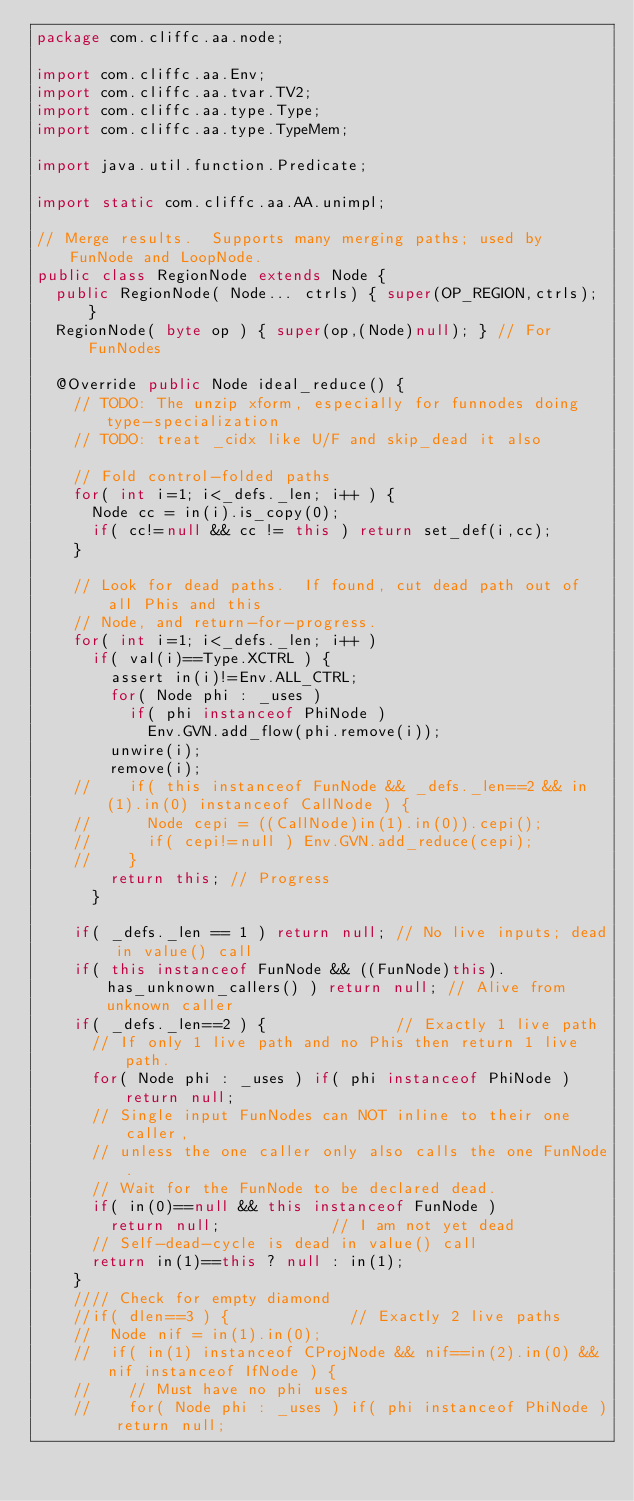Convert code to text. <code><loc_0><loc_0><loc_500><loc_500><_Java_>package com.cliffc.aa.node;

import com.cliffc.aa.Env;
import com.cliffc.aa.tvar.TV2;
import com.cliffc.aa.type.Type;
import com.cliffc.aa.type.TypeMem;

import java.util.function.Predicate;

import static com.cliffc.aa.AA.unimpl;

// Merge results.  Supports many merging paths; used by FunNode and LoopNode.
public class RegionNode extends Node {
  public RegionNode( Node... ctrls) { super(OP_REGION,ctrls); }
  RegionNode( byte op ) { super(op,(Node)null); } // For FunNodes

  @Override public Node ideal_reduce() {
    // TODO: The unzip xform, especially for funnodes doing type-specialization
    // TODO: treat _cidx like U/F and skip_dead it also

    // Fold control-folded paths
    for( int i=1; i<_defs._len; i++ ) {
      Node cc = in(i).is_copy(0);
      if( cc!=null && cc != this ) return set_def(i,cc);
    }

    // Look for dead paths.  If found, cut dead path out of all Phis and this
    // Node, and return-for-progress.
    for( int i=1; i<_defs._len; i++ )
      if( val(i)==Type.XCTRL ) {
        assert in(i)!=Env.ALL_CTRL;
        for( Node phi : _uses )
          if( phi instanceof PhiNode )
            Env.GVN.add_flow(phi.remove(i));
        unwire(i);
        remove(i);
    //    if( this instanceof FunNode && _defs._len==2 && in(1).in(0) instanceof CallNode ) {
    //      Node cepi = ((CallNode)in(1).in(0)).cepi();
    //      if( cepi!=null ) Env.GVN.add_reduce(cepi);
    //    }
        return this; // Progress
      }

    if( _defs._len == 1 ) return null; // No live inputs; dead in value() call
    if( this instanceof FunNode && ((FunNode)this).has_unknown_callers() ) return null; // Alive from unknown caller
    if( _defs._len==2 ) {              // Exactly 1 live path
      // If only 1 live path and no Phis then return 1 live path.
      for( Node phi : _uses ) if( phi instanceof PhiNode ) return null;
      // Single input FunNodes can NOT inline to their one caller,
      // unless the one caller only also calls the one FunNode.
      // Wait for the FunNode to be declared dead.
      if( in(0)==null && this instanceof FunNode )
        return null;            // I am not yet dead
      // Self-dead-cycle is dead in value() call
      return in(1)==this ? null : in(1);
    }
    //// Check for empty diamond
    //if( dlen==3 ) {             // Exactly 2 live paths
    //  Node nif = in(1).in(0);
    //  if( in(1) instanceof CProjNode && nif==in(2).in(0) && nif instanceof IfNode ) {
    //    // Must have no phi uses
    //    for( Node phi : _uses ) if( phi instanceof PhiNode ) return null;</code> 